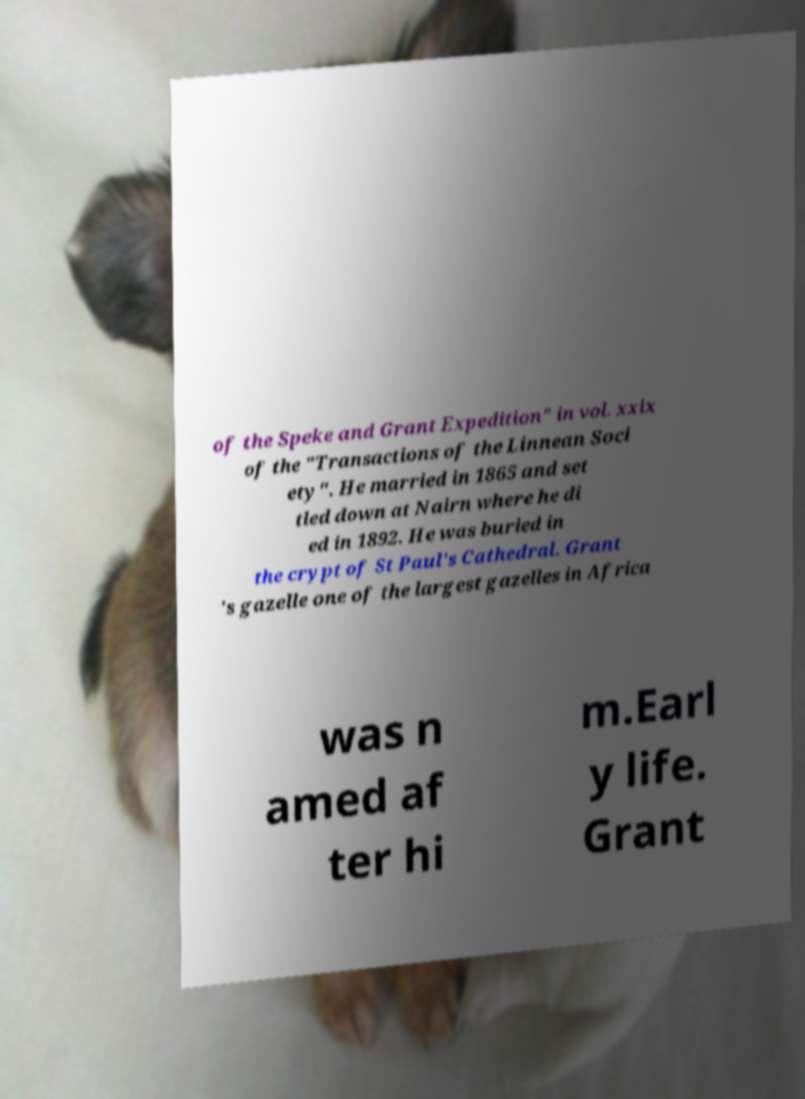Please read and relay the text visible in this image. What does it say? of the Speke and Grant Expedition" in vol. xxix of the "Transactions of the Linnean Soci ety". He married in 1865 and set tled down at Nairn where he di ed in 1892. He was buried in the crypt of St Paul's Cathedral. Grant 's gazelle one of the largest gazelles in Africa was n amed af ter hi m.Earl y life. Grant 